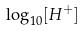Convert formula to latex. <formula><loc_0><loc_0><loc_500><loc_500>\log _ { 1 0 } [ H ^ { + } ]</formula> 